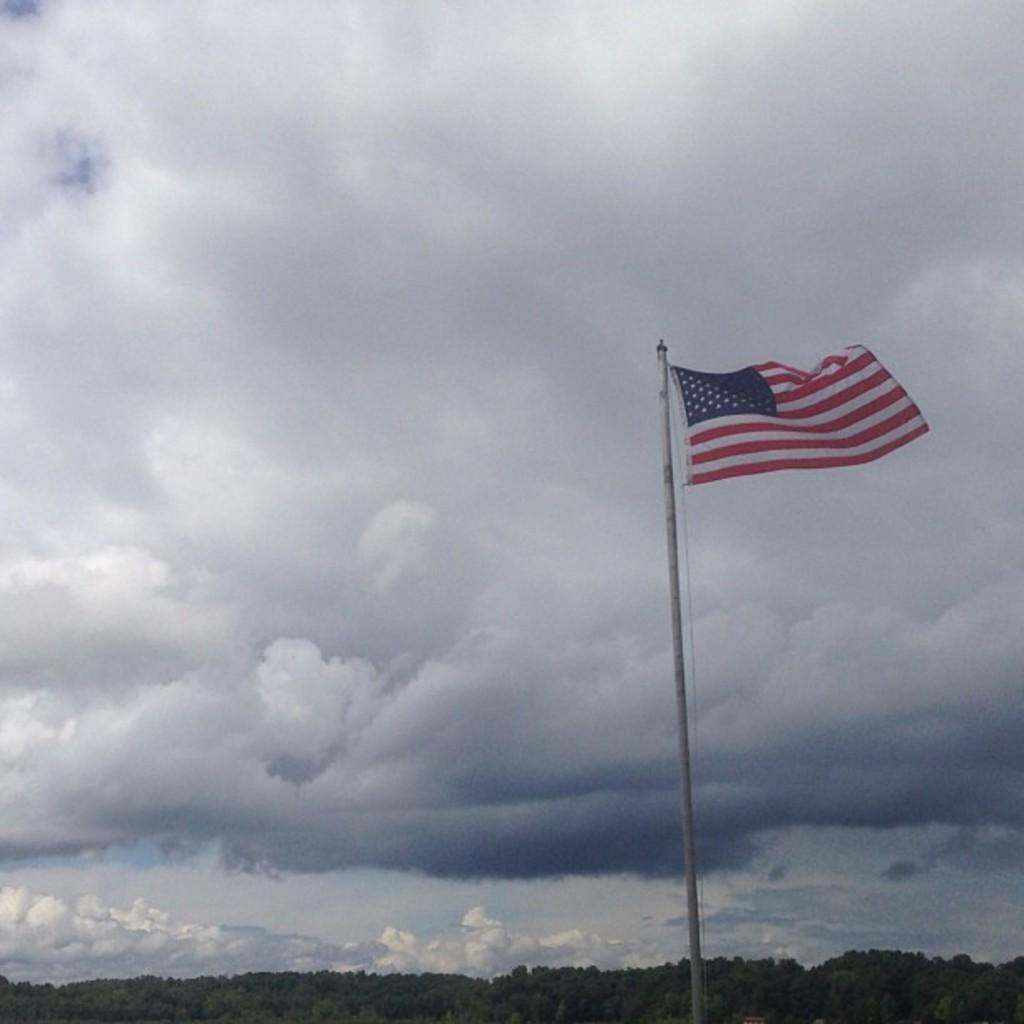What is located on the pole in the image? There is a flag on a pole in the image. What type of vegetation is at the bottom of the image? There are trees at the bottom of the image. What is visible at the top of the image? The sky is visible at the top of the image. How would you describe the sky's appearance in the image? The sky is cloudy in the image. What type of property does the flag have a grip on in the image? There is no property or grip mentioned in the image; it simply features a flag on a pole. 